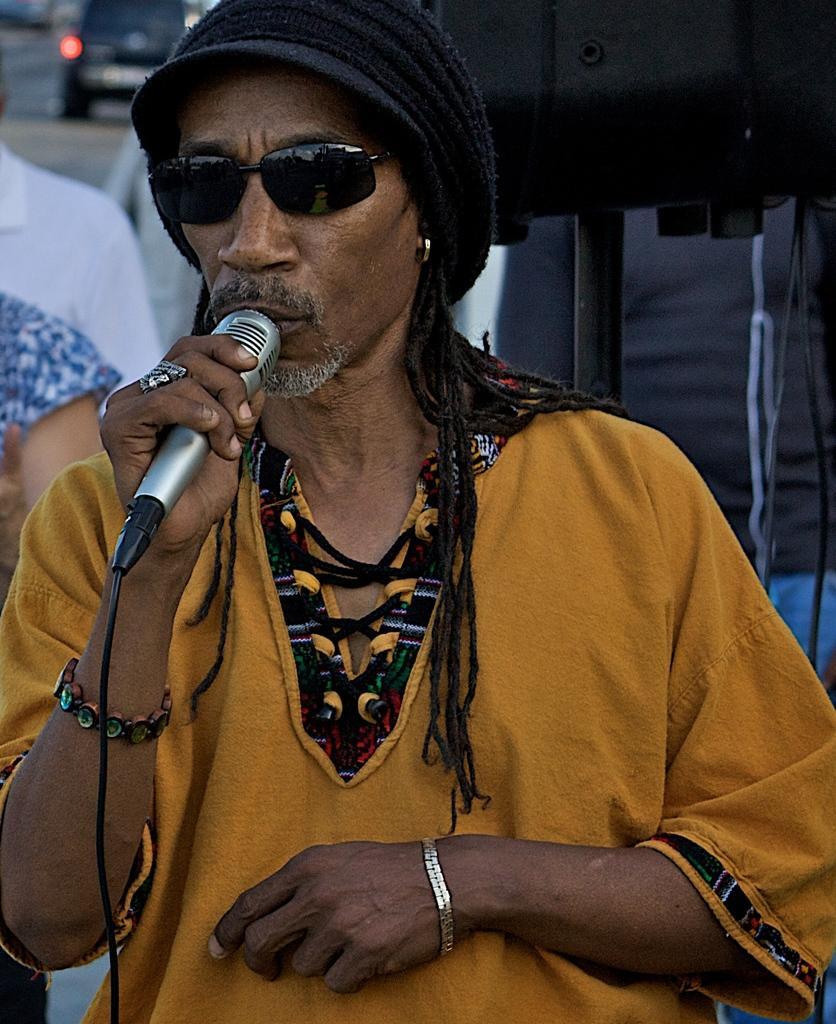Could you give a brief overview of what you see in this image? In front of the picture, we see a man in the yellow shirt is standing. He is holding a microphone in his hands and I think he is singing the song on the microphone. He is wearing the goggles and a black cap. On the left side, we see two men are standing. Behind him, we see a stand and a black color object. In the left top, we see a black car. 